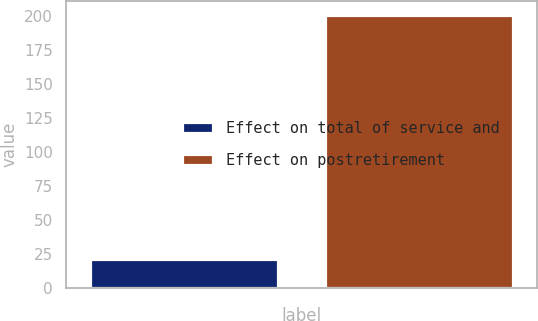Convert chart to OTSL. <chart><loc_0><loc_0><loc_500><loc_500><bar_chart><fcel>Effect on total of service and<fcel>Effect on postretirement<nl><fcel>21<fcel>201<nl></chart> 